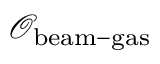Convert formula to latex. <formula><loc_0><loc_0><loc_500><loc_500>\mathcal { O } _ { b e a m - g a s }</formula> 